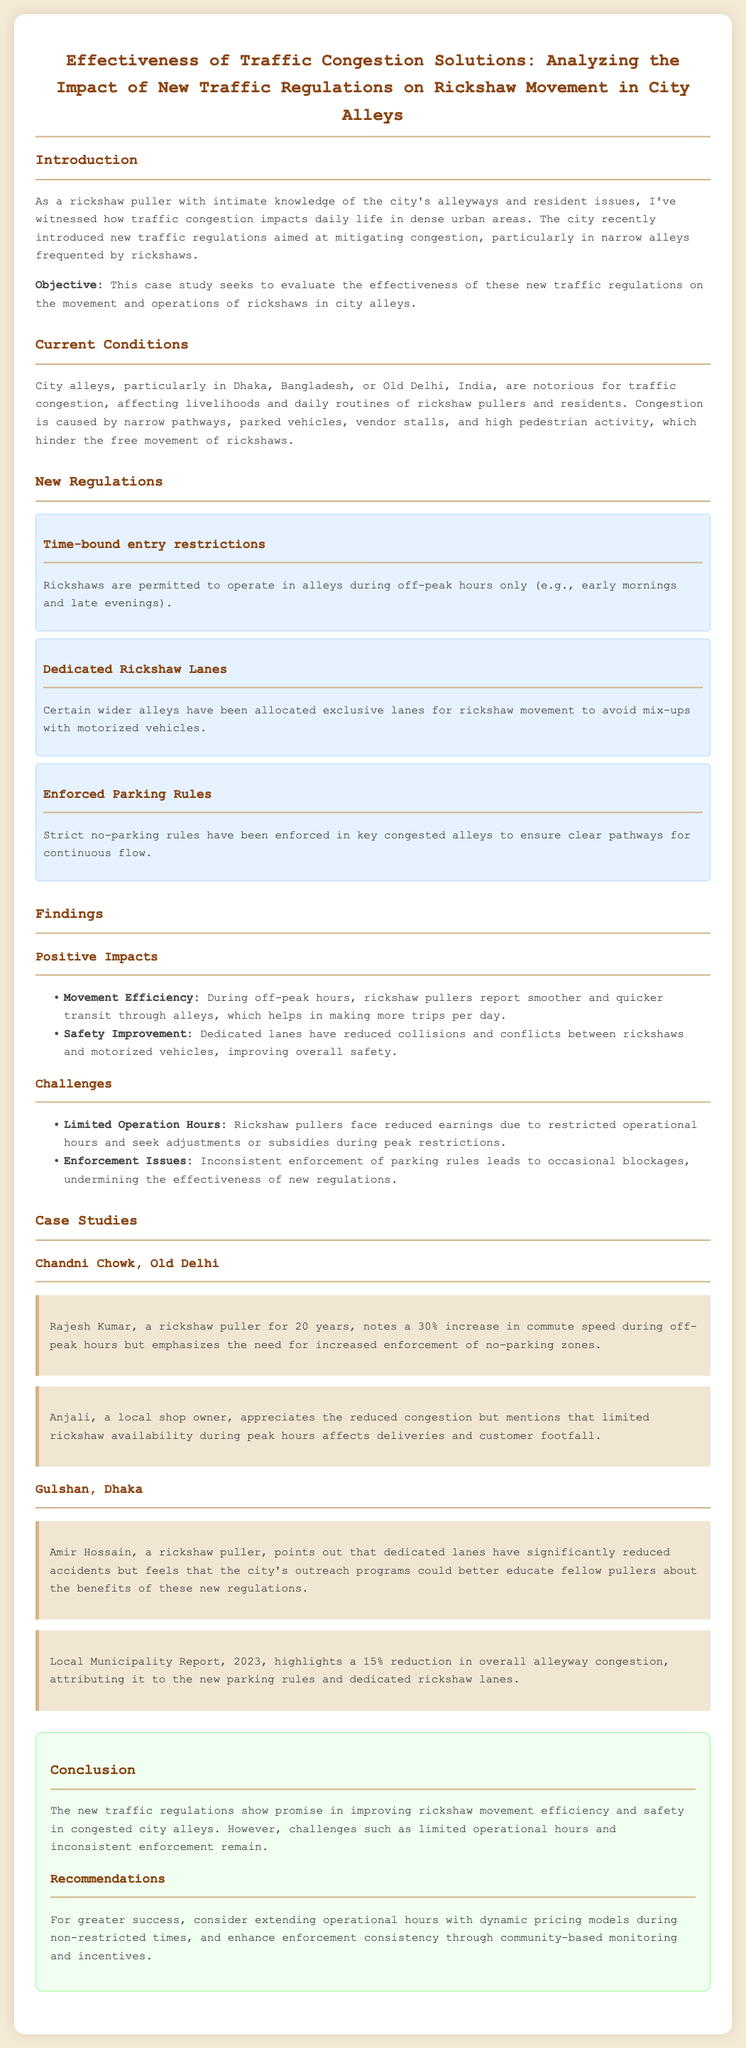What is the objective of the case study? The objective is to evaluate the effectiveness of the new traffic regulations on the movement and operations of rickshaws in city alleys.
Answer: evaluate the effectiveness What are the two cities mentioned in the current conditions? The cities mentioned are Dhaka and Old Delhi.
Answer: Dhaka, Old Delhi What is one positive impact of the new regulations? One positive impact mentioned is movement efficiency, with rickshaw pullers reporting smoother transit.
Answer: movement efficiency What percentage increase in commute speed did Rajesh Kumar report? Rajesh Kumar noted a 30% increase in commute speed during off-peak hours.
Answer: 30% What is one challenge faced by rickshaw pullers due to the new regulations? A challenge faced is reduced earnings due to restricted operational hours.
Answer: reduced earnings What type of lanes have been allocated for rickshaws? Dedicated lanes have been allocated for rickshaw movement.
Answer: Dedicated lanes What year did the Local Municipality Report highlight a reduction in congestion? The Local Municipality Report highlighted a reduction in 2023.
Answer: 2023 What recommendation is given for enhancing enforcement consistency? The recommendation is to enhance enforcement consistency through community-based monitoring and incentives.
Answer: community-based monitoring and incentives 